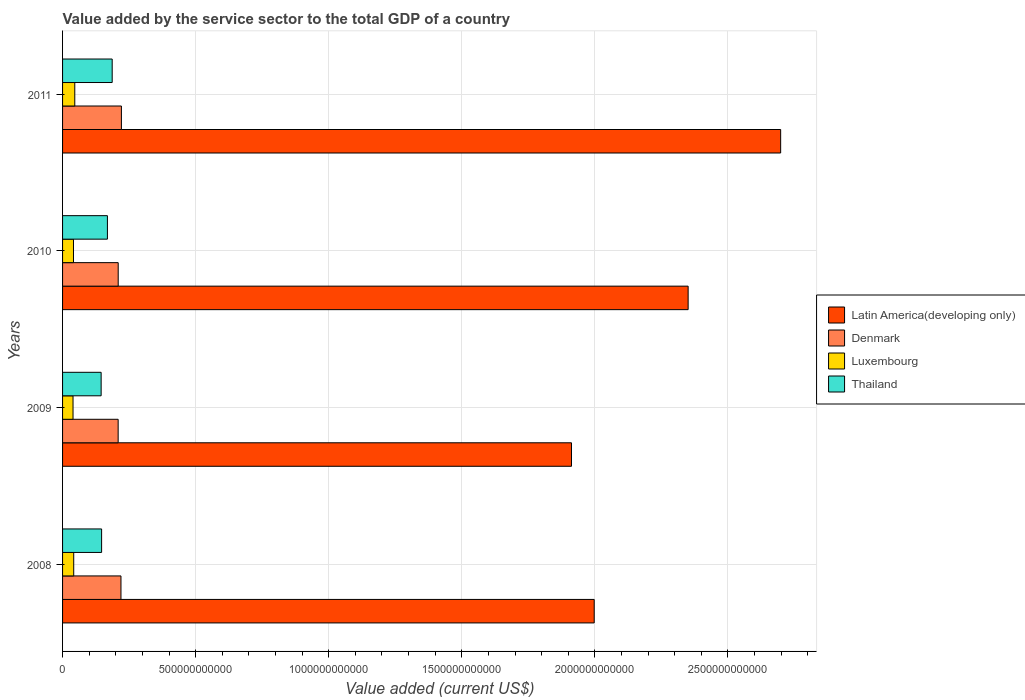How many different coloured bars are there?
Offer a very short reply. 4. What is the label of the 2nd group of bars from the top?
Your answer should be very brief. 2010. What is the value added by the service sector to the total GDP in Latin America(developing only) in 2010?
Your response must be concise. 2.35e+12. Across all years, what is the maximum value added by the service sector to the total GDP in Denmark?
Give a very brief answer. 2.21e+11. Across all years, what is the minimum value added by the service sector to the total GDP in Thailand?
Provide a short and direct response. 1.45e+11. In which year was the value added by the service sector to the total GDP in Thailand minimum?
Provide a succinct answer. 2009. What is the total value added by the service sector to the total GDP in Luxembourg in the graph?
Provide a succinct answer. 1.68e+11. What is the difference between the value added by the service sector to the total GDP in Thailand in 2008 and that in 2009?
Make the answer very short. 1.73e+09. What is the difference between the value added by the service sector to the total GDP in Luxembourg in 2009 and the value added by the service sector to the total GDP in Thailand in 2011?
Keep it short and to the point. -1.47e+11. What is the average value added by the service sector to the total GDP in Thailand per year?
Make the answer very short. 1.62e+11. In the year 2010, what is the difference between the value added by the service sector to the total GDP in Thailand and value added by the service sector to the total GDP in Latin America(developing only)?
Your answer should be very brief. -2.18e+12. In how many years, is the value added by the service sector to the total GDP in Denmark greater than 1700000000000 US$?
Your answer should be compact. 0. What is the ratio of the value added by the service sector to the total GDP in Latin America(developing only) in 2008 to that in 2010?
Make the answer very short. 0.85. What is the difference between the highest and the second highest value added by the service sector to the total GDP in Thailand?
Keep it short and to the point. 1.79e+1. What is the difference between the highest and the lowest value added by the service sector to the total GDP in Thailand?
Your answer should be compact. 4.15e+1. In how many years, is the value added by the service sector to the total GDP in Luxembourg greater than the average value added by the service sector to the total GDP in Luxembourg taken over all years?
Give a very brief answer. 1. Is the sum of the value added by the service sector to the total GDP in Denmark in 2009 and 2011 greater than the maximum value added by the service sector to the total GDP in Thailand across all years?
Provide a succinct answer. Yes. What does the 1st bar from the top in 2008 represents?
Your response must be concise. Thailand. What does the 3rd bar from the bottom in 2010 represents?
Your response must be concise. Luxembourg. Is it the case that in every year, the sum of the value added by the service sector to the total GDP in Denmark and value added by the service sector to the total GDP in Luxembourg is greater than the value added by the service sector to the total GDP in Latin America(developing only)?
Offer a terse response. No. Are all the bars in the graph horizontal?
Your response must be concise. Yes. How many years are there in the graph?
Your answer should be compact. 4. What is the difference between two consecutive major ticks on the X-axis?
Give a very brief answer. 5.00e+11. Does the graph contain any zero values?
Provide a succinct answer. No. Does the graph contain grids?
Offer a very short reply. Yes. Where does the legend appear in the graph?
Ensure brevity in your answer.  Center right. How many legend labels are there?
Offer a very short reply. 4. How are the legend labels stacked?
Provide a succinct answer. Vertical. What is the title of the graph?
Offer a very short reply. Value added by the service sector to the total GDP of a country. Does "Venezuela" appear as one of the legend labels in the graph?
Provide a succinct answer. No. What is the label or title of the X-axis?
Give a very brief answer. Value added (current US$). What is the Value added (current US$) in Latin America(developing only) in 2008?
Keep it short and to the point. 2.00e+12. What is the Value added (current US$) in Denmark in 2008?
Offer a terse response. 2.19e+11. What is the Value added (current US$) in Luxembourg in 2008?
Keep it short and to the point. 4.19e+1. What is the Value added (current US$) of Thailand in 2008?
Make the answer very short. 1.47e+11. What is the Value added (current US$) of Latin America(developing only) in 2009?
Provide a short and direct response. 1.91e+12. What is the Value added (current US$) in Denmark in 2009?
Give a very brief answer. 2.09e+11. What is the Value added (current US$) in Luxembourg in 2009?
Provide a short and direct response. 3.93e+1. What is the Value added (current US$) of Thailand in 2009?
Your answer should be very brief. 1.45e+11. What is the Value added (current US$) of Latin America(developing only) in 2010?
Ensure brevity in your answer.  2.35e+12. What is the Value added (current US$) in Denmark in 2010?
Keep it short and to the point. 2.09e+11. What is the Value added (current US$) in Luxembourg in 2010?
Make the answer very short. 4.10e+1. What is the Value added (current US$) in Thailand in 2010?
Provide a succinct answer. 1.69e+11. What is the Value added (current US$) in Latin America(developing only) in 2011?
Make the answer very short. 2.70e+12. What is the Value added (current US$) in Denmark in 2011?
Your response must be concise. 2.21e+11. What is the Value added (current US$) in Luxembourg in 2011?
Offer a very short reply. 4.59e+1. What is the Value added (current US$) in Thailand in 2011?
Ensure brevity in your answer.  1.86e+11. Across all years, what is the maximum Value added (current US$) of Latin America(developing only)?
Ensure brevity in your answer.  2.70e+12. Across all years, what is the maximum Value added (current US$) of Denmark?
Provide a succinct answer. 2.21e+11. Across all years, what is the maximum Value added (current US$) of Luxembourg?
Offer a terse response. 4.59e+1. Across all years, what is the maximum Value added (current US$) of Thailand?
Your response must be concise. 1.86e+11. Across all years, what is the minimum Value added (current US$) in Latin America(developing only)?
Provide a short and direct response. 1.91e+12. Across all years, what is the minimum Value added (current US$) in Denmark?
Keep it short and to the point. 2.09e+11. Across all years, what is the minimum Value added (current US$) of Luxembourg?
Keep it short and to the point. 3.93e+1. Across all years, what is the minimum Value added (current US$) in Thailand?
Your answer should be compact. 1.45e+11. What is the total Value added (current US$) of Latin America(developing only) in the graph?
Keep it short and to the point. 8.96e+12. What is the total Value added (current US$) of Denmark in the graph?
Offer a very short reply. 8.58e+11. What is the total Value added (current US$) in Luxembourg in the graph?
Give a very brief answer. 1.68e+11. What is the total Value added (current US$) in Thailand in the graph?
Make the answer very short. 6.47e+11. What is the difference between the Value added (current US$) of Latin America(developing only) in 2008 and that in 2009?
Ensure brevity in your answer.  8.53e+1. What is the difference between the Value added (current US$) of Denmark in 2008 and that in 2009?
Give a very brief answer. 1.05e+1. What is the difference between the Value added (current US$) of Luxembourg in 2008 and that in 2009?
Keep it short and to the point. 2.56e+09. What is the difference between the Value added (current US$) of Thailand in 2008 and that in 2009?
Ensure brevity in your answer.  1.73e+09. What is the difference between the Value added (current US$) of Latin America(developing only) in 2008 and that in 2010?
Offer a very short reply. -3.53e+11. What is the difference between the Value added (current US$) of Denmark in 2008 and that in 2010?
Provide a short and direct response. 1.04e+1. What is the difference between the Value added (current US$) in Luxembourg in 2008 and that in 2010?
Provide a short and direct response. 8.35e+08. What is the difference between the Value added (current US$) of Thailand in 2008 and that in 2010?
Keep it short and to the point. -2.19e+1. What is the difference between the Value added (current US$) of Latin America(developing only) in 2008 and that in 2011?
Provide a succinct answer. -7.00e+11. What is the difference between the Value added (current US$) of Denmark in 2008 and that in 2011?
Ensure brevity in your answer.  -1.67e+09. What is the difference between the Value added (current US$) of Luxembourg in 2008 and that in 2011?
Give a very brief answer. -4.02e+09. What is the difference between the Value added (current US$) in Thailand in 2008 and that in 2011?
Provide a short and direct response. -3.98e+1. What is the difference between the Value added (current US$) in Latin America(developing only) in 2009 and that in 2010?
Your answer should be very brief. -4.38e+11. What is the difference between the Value added (current US$) of Denmark in 2009 and that in 2010?
Keep it short and to the point. -1.75e+08. What is the difference between the Value added (current US$) of Luxembourg in 2009 and that in 2010?
Provide a succinct answer. -1.73e+09. What is the difference between the Value added (current US$) of Thailand in 2009 and that in 2010?
Give a very brief answer. -2.36e+1. What is the difference between the Value added (current US$) of Latin America(developing only) in 2009 and that in 2011?
Your answer should be compact. -7.86e+11. What is the difference between the Value added (current US$) of Denmark in 2009 and that in 2011?
Provide a succinct answer. -1.22e+1. What is the difference between the Value added (current US$) in Luxembourg in 2009 and that in 2011?
Provide a succinct answer. -6.58e+09. What is the difference between the Value added (current US$) in Thailand in 2009 and that in 2011?
Keep it short and to the point. -4.15e+1. What is the difference between the Value added (current US$) of Latin America(developing only) in 2010 and that in 2011?
Your answer should be compact. -3.48e+11. What is the difference between the Value added (current US$) in Denmark in 2010 and that in 2011?
Offer a terse response. -1.20e+1. What is the difference between the Value added (current US$) of Luxembourg in 2010 and that in 2011?
Offer a terse response. -4.85e+09. What is the difference between the Value added (current US$) of Thailand in 2010 and that in 2011?
Your response must be concise. -1.79e+1. What is the difference between the Value added (current US$) of Latin America(developing only) in 2008 and the Value added (current US$) of Denmark in 2009?
Provide a succinct answer. 1.79e+12. What is the difference between the Value added (current US$) of Latin America(developing only) in 2008 and the Value added (current US$) of Luxembourg in 2009?
Give a very brief answer. 1.96e+12. What is the difference between the Value added (current US$) of Latin America(developing only) in 2008 and the Value added (current US$) of Thailand in 2009?
Provide a succinct answer. 1.85e+12. What is the difference between the Value added (current US$) in Denmark in 2008 and the Value added (current US$) in Luxembourg in 2009?
Ensure brevity in your answer.  1.80e+11. What is the difference between the Value added (current US$) of Denmark in 2008 and the Value added (current US$) of Thailand in 2009?
Your answer should be compact. 7.44e+1. What is the difference between the Value added (current US$) in Luxembourg in 2008 and the Value added (current US$) in Thailand in 2009?
Offer a terse response. -1.03e+11. What is the difference between the Value added (current US$) in Latin America(developing only) in 2008 and the Value added (current US$) in Denmark in 2010?
Offer a very short reply. 1.79e+12. What is the difference between the Value added (current US$) of Latin America(developing only) in 2008 and the Value added (current US$) of Luxembourg in 2010?
Provide a short and direct response. 1.96e+12. What is the difference between the Value added (current US$) in Latin America(developing only) in 2008 and the Value added (current US$) in Thailand in 2010?
Give a very brief answer. 1.83e+12. What is the difference between the Value added (current US$) in Denmark in 2008 and the Value added (current US$) in Luxembourg in 2010?
Your answer should be compact. 1.78e+11. What is the difference between the Value added (current US$) in Denmark in 2008 and the Value added (current US$) in Thailand in 2010?
Make the answer very short. 5.09e+1. What is the difference between the Value added (current US$) in Luxembourg in 2008 and the Value added (current US$) in Thailand in 2010?
Provide a short and direct response. -1.27e+11. What is the difference between the Value added (current US$) of Latin America(developing only) in 2008 and the Value added (current US$) of Denmark in 2011?
Provide a short and direct response. 1.78e+12. What is the difference between the Value added (current US$) of Latin America(developing only) in 2008 and the Value added (current US$) of Luxembourg in 2011?
Make the answer very short. 1.95e+12. What is the difference between the Value added (current US$) of Latin America(developing only) in 2008 and the Value added (current US$) of Thailand in 2011?
Ensure brevity in your answer.  1.81e+12. What is the difference between the Value added (current US$) in Denmark in 2008 and the Value added (current US$) in Luxembourg in 2011?
Provide a short and direct response. 1.74e+11. What is the difference between the Value added (current US$) in Denmark in 2008 and the Value added (current US$) in Thailand in 2011?
Your response must be concise. 3.30e+1. What is the difference between the Value added (current US$) in Luxembourg in 2008 and the Value added (current US$) in Thailand in 2011?
Give a very brief answer. -1.45e+11. What is the difference between the Value added (current US$) in Latin America(developing only) in 2009 and the Value added (current US$) in Denmark in 2010?
Your response must be concise. 1.70e+12. What is the difference between the Value added (current US$) in Latin America(developing only) in 2009 and the Value added (current US$) in Luxembourg in 2010?
Provide a short and direct response. 1.87e+12. What is the difference between the Value added (current US$) of Latin America(developing only) in 2009 and the Value added (current US$) of Thailand in 2010?
Keep it short and to the point. 1.74e+12. What is the difference between the Value added (current US$) in Denmark in 2009 and the Value added (current US$) in Luxembourg in 2010?
Provide a succinct answer. 1.68e+11. What is the difference between the Value added (current US$) in Denmark in 2009 and the Value added (current US$) in Thailand in 2010?
Provide a short and direct response. 4.03e+1. What is the difference between the Value added (current US$) of Luxembourg in 2009 and the Value added (current US$) of Thailand in 2010?
Offer a very short reply. -1.29e+11. What is the difference between the Value added (current US$) of Latin America(developing only) in 2009 and the Value added (current US$) of Denmark in 2011?
Your answer should be compact. 1.69e+12. What is the difference between the Value added (current US$) of Latin America(developing only) in 2009 and the Value added (current US$) of Luxembourg in 2011?
Offer a very short reply. 1.87e+12. What is the difference between the Value added (current US$) in Latin America(developing only) in 2009 and the Value added (current US$) in Thailand in 2011?
Offer a terse response. 1.73e+12. What is the difference between the Value added (current US$) in Denmark in 2009 and the Value added (current US$) in Luxembourg in 2011?
Keep it short and to the point. 1.63e+11. What is the difference between the Value added (current US$) of Denmark in 2009 and the Value added (current US$) of Thailand in 2011?
Make the answer very short. 2.24e+1. What is the difference between the Value added (current US$) of Luxembourg in 2009 and the Value added (current US$) of Thailand in 2011?
Your response must be concise. -1.47e+11. What is the difference between the Value added (current US$) of Latin America(developing only) in 2010 and the Value added (current US$) of Denmark in 2011?
Keep it short and to the point. 2.13e+12. What is the difference between the Value added (current US$) of Latin America(developing only) in 2010 and the Value added (current US$) of Luxembourg in 2011?
Your answer should be compact. 2.30e+12. What is the difference between the Value added (current US$) of Latin America(developing only) in 2010 and the Value added (current US$) of Thailand in 2011?
Provide a short and direct response. 2.16e+12. What is the difference between the Value added (current US$) in Denmark in 2010 and the Value added (current US$) in Luxembourg in 2011?
Your answer should be very brief. 1.63e+11. What is the difference between the Value added (current US$) of Denmark in 2010 and the Value added (current US$) of Thailand in 2011?
Ensure brevity in your answer.  2.26e+1. What is the difference between the Value added (current US$) of Luxembourg in 2010 and the Value added (current US$) of Thailand in 2011?
Ensure brevity in your answer.  -1.45e+11. What is the average Value added (current US$) of Latin America(developing only) per year?
Offer a very short reply. 2.24e+12. What is the average Value added (current US$) in Denmark per year?
Keep it short and to the point. 2.15e+11. What is the average Value added (current US$) in Luxembourg per year?
Offer a very short reply. 4.20e+1. What is the average Value added (current US$) in Thailand per year?
Your answer should be very brief. 1.62e+11. In the year 2008, what is the difference between the Value added (current US$) of Latin America(developing only) and Value added (current US$) of Denmark?
Your response must be concise. 1.78e+12. In the year 2008, what is the difference between the Value added (current US$) of Latin America(developing only) and Value added (current US$) of Luxembourg?
Offer a terse response. 1.96e+12. In the year 2008, what is the difference between the Value added (current US$) in Latin America(developing only) and Value added (current US$) in Thailand?
Provide a succinct answer. 1.85e+12. In the year 2008, what is the difference between the Value added (current US$) in Denmark and Value added (current US$) in Luxembourg?
Your answer should be very brief. 1.78e+11. In the year 2008, what is the difference between the Value added (current US$) of Denmark and Value added (current US$) of Thailand?
Offer a terse response. 7.27e+1. In the year 2008, what is the difference between the Value added (current US$) in Luxembourg and Value added (current US$) in Thailand?
Give a very brief answer. -1.05e+11. In the year 2009, what is the difference between the Value added (current US$) in Latin America(developing only) and Value added (current US$) in Denmark?
Your response must be concise. 1.70e+12. In the year 2009, what is the difference between the Value added (current US$) of Latin America(developing only) and Value added (current US$) of Luxembourg?
Keep it short and to the point. 1.87e+12. In the year 2009, what is the difference between the Value added (current US$) in Latin America(developing only) and Value added (current US$) in Thailand?
Give a very brief answer. 1.77e+12. In the year 2009, what is the difference between the Value added (current US$) of Denmark and Value added (current US$) of Luxembourg?
Your answer should be compact. 1.70e+11. In the year 2009, what is the difference between the Value added (current US$) in Denmark and Value added (current US$) in Thailand?
Provide a short and direct response. 6.39e+1. In the year 2009, what is the difference between the Value added (current US$) in Luxembourg and Value added (current US$) in Thailand?
Offer a terse response. -1.06e+11. In the year 2010, what is the difference between the Value added (current US$) in Latin America(developing only) and Value added (current US$) in Denmark?
Make the answer very short. 2.14e+12. In the year 2010, what is the difference between the Value added (current US$) in Latin America(developing only) and Value added (current US$) in Luxembourg?
Provide a short and direct response. 2.31e+12. In the year 2010, what is the difference between the Value added (current US$) in Latin America(developing only) and Value added (current US$) in Thailand?
Ensure brevity in your answer.  2.18e+12. In the year 2010, what is the difference between the Value added (current US$) of Denmark and Value added (current US$) of Luxembourg?
Provide a succinct answer. 1.68e+11. In the year 2010, what is the difference between the Value added (current US$) of Denmark and Value added (current US$) of Thailand?
Give a very brief answer. 4.05e+1. In the year 2010, what is the difference between the Value added (current US$) in Luxembourg and Value added (current US$) in Thailand?
Ensure brevity in your answer.  -1.27e+11. In the year 2011, what is the difference between the Value added (current US$) of Latin America(developing only) and Value added (current US$) of Denmark?
Your response must be concise. 2.48e+12. In the year 2011, what is the difference between the Value added (current US$) of Latin America(developing only) and Value added (current US$) of Luxembourg?
Keep it short and to the point. 2.65e+12. In the year 2011, what is the difference between the Value added (current US$) in Latin America(developing only) and Value added (current US$) in Thailand?
Provide a short and direct response. 2.51e+12. In the year 2011, what is the difference between the Value added (current US$) of Denmark and Value added (current US$) of Luxembourg?
Give a very brief answer. 1.75e+11. In the year 2011, what is the difference between the Value added (current US$) in Denmark and Value added (current US$) in Thailand?
Your response must be concise. 3.46e+1. In the year 2011, what is the difference between the Value added (current US$) in Luxembourg and Value added (current US$) in Thailand?
Give a very brief answer. -1.41e+11. What is the ratio of the Value added (current US$) of Latin America(developing only) in 2008 to that in 2009?
Your answer should be compact. 1.04. What is the ratio of the Value added (current US$) of Denmark in 2008 to that in 2009?
Provide a succinct answer. 1.05. What is the ratio of the Value added (current US$) in Luxembourg in 2008 to that in 2009?
Your response must be concise. 1.07. What is the ratio of the Value added (current US$) of Thailand in 2008 to that in 2009?
Ensure brevity in your answer.  1.01. What is the ratio of the Value added (current US$) of Latin America(developing only) in 2008 to that in 2010?
Your answer should be very brief. 0.85. What is the ratio of the Value added (current US$) of Denmark in 2008 to that in 2010?
Offer a terse response. 1.05. What is the ratio of the Value added (current US$) in Luxembourg in 2008 to that in 2010?
Make the answer very short. 1.02. What is the ratio of the Value added (current US$) in Thailand in 2008 to that in 2010?
Your answer should be compact. 0.87. What is the ratio of the Value added (current US$) in Latin America(developing only) in 2008 to that in 2011?
Your answer should be very brief. 0.74. What is the ratio of the Value added (current US$) in Denmark in 2008 to that in 2011?
Provide a succinct answer. 0.99. What is the ratio of the Value added (current US$) of Luxembourg in 2008 to that in 2011?
Give a very brief answer. 0.91. What is the ratio of the Value added (current US$) in Thailand in 2008 to that in 2011?
Offer a terse response. 0.79. What is the ratio of the Value added (current US$) in Latin America(developing only) in 2009 to that in 2010?
Keep it short and to the point. 0.81. What is the ratio of the Value added (current US$) in Luxembourg in 2009 to that in 2010?
Your answer should be very brief. 0.96. What is the ratio of the Value added (current US$) of Thailand in 2009 to that in 2010?
Ensure brevity in your answer.  0.86. What is the ratio of the Value added (current US$) in Latin America(developing only) in 2009 to that in 2011?
Provide a short and direct response. 0.71. What is the ratio of the Value added (current US$) of Denmark in 2009 to that in 2011?
Keep it short and to the point. 0.94. What is the ratio of the Value added (current US$) in Luxembourg in 2009 to that in 2011?
Your answer should be very brief. 0.86. What is the ratio of the Value added (current US$) in Thailand in 2009 to that in 2011?
Provide a short and direct response. 0.78. What is the ratio of the Value added (current US$) in Latin America(developing only) in 2010 to that in 2011?
Offer a terse response. 0.87. What is the ratio of the Value added (current US$) of Denmark in 2010 to that in 2011?
Make the answer very short. 0.95. What is the ratio of the Value added (current US$) of Luxembourg in 2010 to that in 2011?
Offer a terse response. 0.89. What is the ratio of the Value added (current US$) in Thailand in 2010 to that in 2011?
Offer a very short reply. 0.9. What is the difference between the highest and the second highest Value added (current US$) in Latin America(developing only)?
Provide a succinct answer. 3.48e+11. What is the difference between the highest and the second highest Value added (current US$) in Denmark?
Keep it short and to the point. 1.67e+09. What is the difference between the highest and the second highest Value added (current US$) in Luxembourg?
Your answer should be compact. 4.02e+09. What is the difference between the highest and the second highest Value added (current US$) in Thailand?
Offer a terse response. 1.79e+1. What is the difference between the highest and the lowest Value added (current US$) in Latin America(developing only)?
Make the answer very short. 7.86e+11. What is the difference between the highest and the lowest Value added (current US$) of Denmark?
Keep it short and to the point. 1.22e+1. What is the difference between the highest and the lowest Value added (current US$) in Luxembourg?
Your answer should be very brief. 6.58e+09. What is the difference between the highest and the lowest Value added (current US$) of Thailand?
Provide a short and direct response. 4.15e+1. 